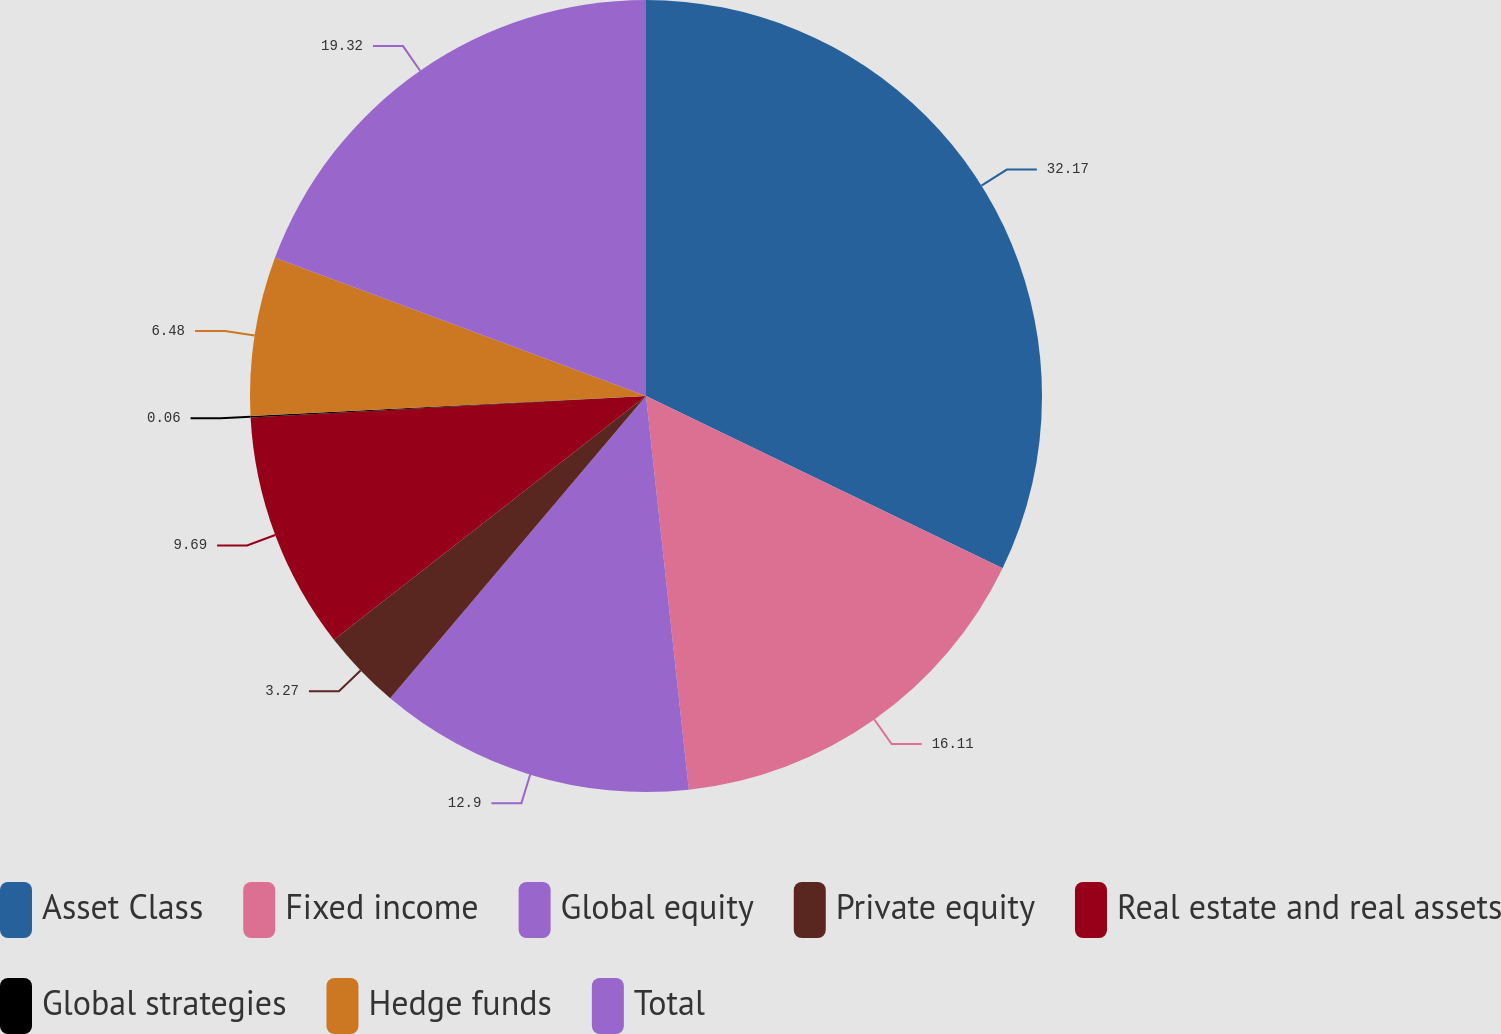Convert chart to OTSL. <chart><loc_0><loc_0><loc_500><loc_500><pie_chart><fcel>Asset Class<fcel>Fixed income<fcel>Global equity<fcel>Private equity<fcel>Real estate and real assets<fcel>Global strategies<fcel>Hedge funds<fcel>Total<nl><fcel>32.16%<fcel>16.11%<fcel>12.9%<fcel>3.27%<fcel>9.69%<fcel>0.06%<fcel>6.48%<fcel>19.32%<nl></chart> 